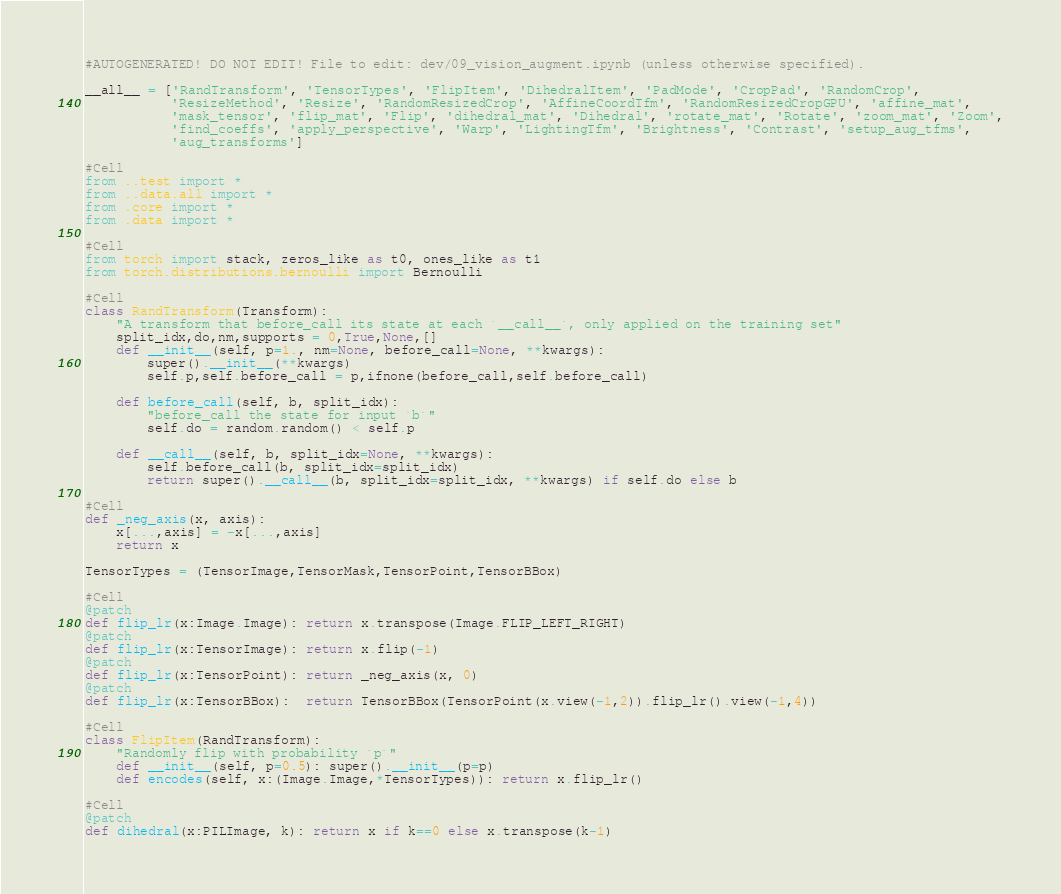Convert code to text. <code><loc_0><loc_0><loc_500><loc_500><_Python_>#AUTOGENERATED! DO NOT EDIT! File to edit: dev/09_vision_augment.ipynb (unless otherwise specified).

__all__ = ['RandTransform', 'TensorTypes', 'FlipItem', 'DihedralItem', 'PadMode', 'CropPad', 'RandomCrop',
           'ResizeMethod', 'Resize', 'RandomResizedCrop', 'AffineCoordTfm', 'RandomResizedCropGPU', 'affine_mat',
           'mask_tensor', 'flip_mat', 'Flip', 'dihedral_mat', 'Dihedral', 'rotate_mat', 'Rotate', 'zoom_mat', 'Zoom',
           'find_coeffs', 'apply_perspective', 'Warp', 'LightingTfm', 'Brightness', 'Contrast', 'setup_aug_tfms',
           'aug_transforms']

#Cell
from ..test import *
from ..data.all import *
from .core import *
from .data import *

#Cell
from torch import stack, zeros_like as t0, ones_like as t1
from torch.distributions.bernoulli import Bernoulli

#Cell
class RandTransform(Transform):
    "A transform that before_call its state at each `__call__`, only applied on the training set"
    split_idx,do,nm,supports = 0,True,None,[]
    def __init__(self, p=1., nm=None, before_call=None, **kwargs):
        super().__init__(**kwargs)
        self.p,self.before_call = p,ifnone(before_call,self.before_call)

    def before_call(self, b, split_idx):
        "before_call the state for input `b`"
        self.do = random.random() < self.p

    def __call__(self, b, split_idx=None, **kwargs):
        self.before_call(b, split_idx=split_idx)
        return super().__call__(b, split_idx=split_idx, **kwargs) if self.do else b

#Cell
def _neg_axis(x, axis):
    x[...,axis] = -x[...,axis]
    return x

TensorTypes = (TensorImage,TensorMask,TensorPoint,TensorBBox)

#Cell
@patch
def flip_lr(x:Image.Image): return x.transpose(Image.FLIP_LEFT_RIGHT)
@patch
def flip_lr(x:TensorImage): return x.flip(-1)
@patch
def flip_lr(x:TensorPoint): return _neg_axis(x, 0)
@patch
def flip_lr(x:TensorBBox):  return TensorBBox(TensorPoint(x.view(-1,2)).flip_lr().view(-1,4))

#Cell
class FlipItem(RandTransform):
    "Randomly flip with probability `p`"
    def __init__(self, p=0.5): super().__init__(p=p)
    def encodes(self, x:(Image.Image,*TensorTypes)): return x.flip_lr()

#Cell
@patch
def dihedral(x:PILImage, k): return x if k==0 else x.transpose(k-1)</code> 